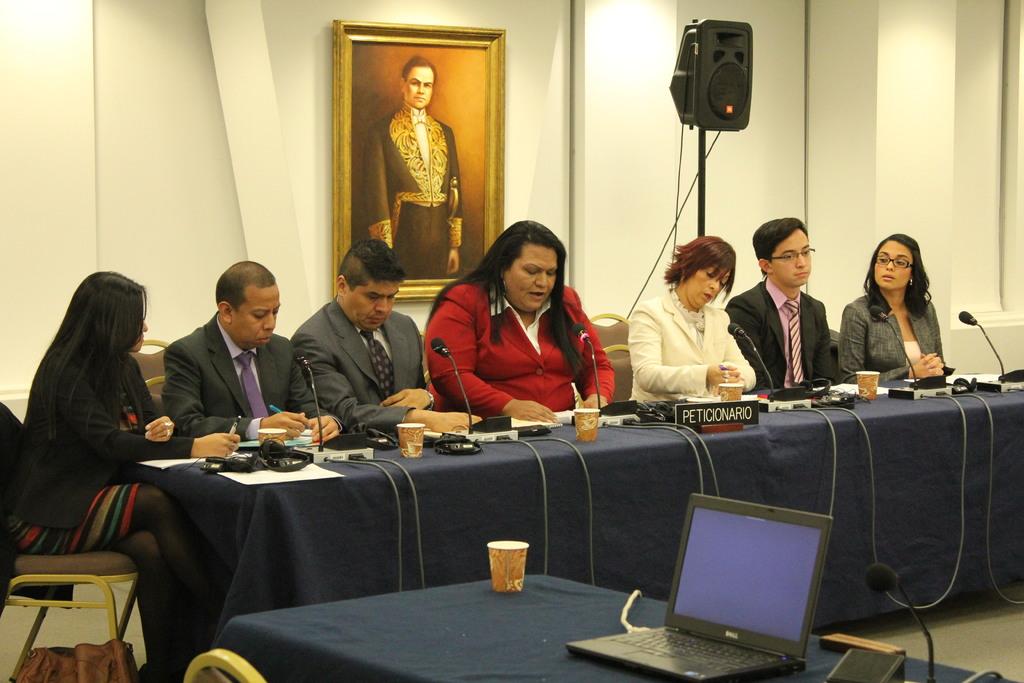What name is on the nametag?
Give a very brief answer. Peticionario. In meeting is going?
Keep it short and to the point. Yes. 